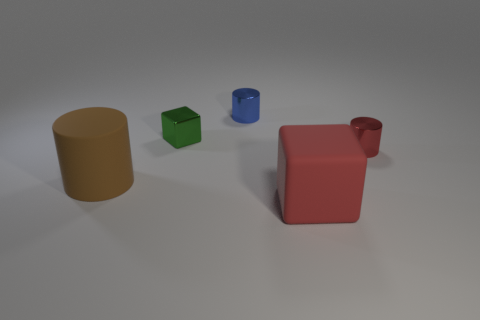Add 3 big purple matte balls. How many objects exist? 8 Subtract all shiny cylinders. How many cylinders are left? 1 Subtract all brown cylinders. How many cylinders are left? 2 Subtract 1 blocks. How many blocks are left? 1 Subtract all cylinders. How many objects are left? 2 Subtract all yellow cylinders. Subtract all yellow spheres. How many cylinders are left? 3 Subtract all red blocks. Subtract all large red cubes. How many objects are left? 3 Add 5 red objects. How many red objects are left? 7 Add 5 matte cylinders. How many matte cylinders exist? 6 Subtract 0 cyan cylinders. How many objects are left? 5 